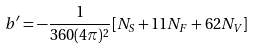<formula> <loc_0><loc_0><loc_500><loc_500>b ^ { \prime } = - \frac { 1 } { 3 6 0 ( 4 \pi ) ^ { 2 } } [ N _ { S } + 1 1 N _ { F } + 6 2 N _ { V } ]</formula> 